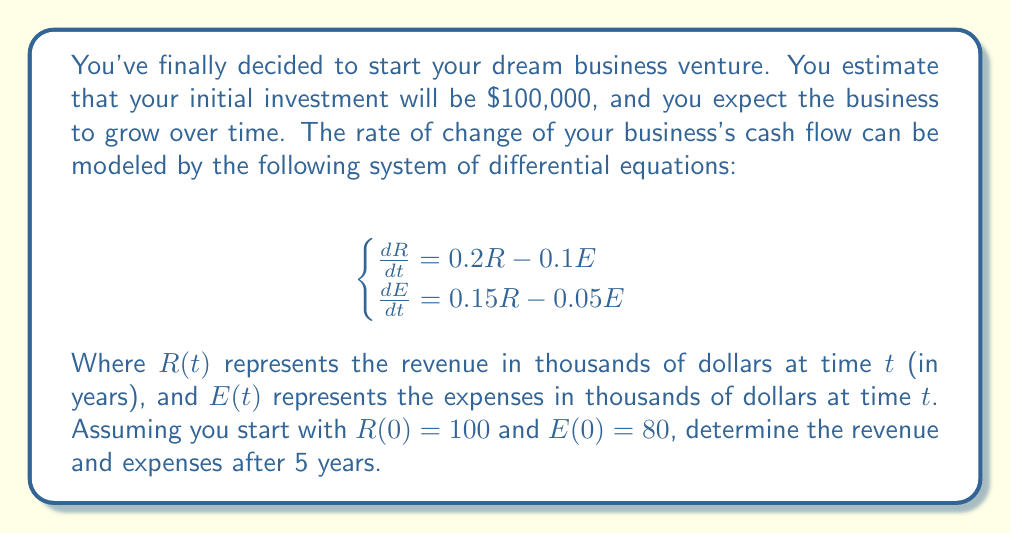What is the answer to this math problem? To solve this system of differential equations, we'll use the eigenvalue method:

1) First, write the system in matrix form:
   $$\frac{d}{dt}\begin{bmatrix} R \\ E \end{bmatrix} = \begin{bmatrix} 0.2 & -0.1 \\ 0.15 & -0.05 \end{bmatrix}\begin{bmatrix} R \\ E \end{bmatrix}$$

2) Find the eigenvalues by solving $\det(A - \lambda I) = 0$:
   $$\det\begin{bmatrix} 0.2-\lambda & -0.1 \\ 0.15 & -0.05-\lambda \end{bmatrix} = 0$$
   $$(0.2-\lambda)(-0.05-\lambda) - (-0.1)(0.15) = 0$$
   $$\lambda^2 - 0.15\lambda - 0.025 = 0$$
   Solving this quadratic equation gives: $\lambda_1 \approx 0.1789$ and $\lambda_2 \approx -0.0289$

3) Find the eigenvectors for each eigenvalue:
   For $\lambda_1 \approx 0.1789$: $\vec{v_1} \approx \begin{bmatrix} 1 \\ 1.3789 \end{bmatrix}$
   For $\lambda_2 \approx -0.0289$: $\vec{v_2} \approx \begin{bmatrix} 1 \\ -0.3789 \end{bmatrix}$

4) The general solution is:
   $$\begin{bmatrix} R(t) \\ E(t) \end{bmatrix} = c_1e^{0.1789t}\begin{bmatrix} 1 \\ 1.3789 \end{bmatrix} + c_2e^{-0.0289t}\begin{bmatrix} 1 \\ -0.3789 \end{bmatrix}$$

5) Use the initial conditions to find $c_1$ and $c_2$:
   $$\begin{bmatrix} 100 \\ 80 \end{bmatrix} = c_1\begin{bmatrix} 1 \\ 1.3789 \end{bmatrix} + c_2\begin{bmatrix} 1 \\ -0.3789 \end{bmatrix}$$
   Solving this system gives: $c_1 \approx 84.8485$ and $c_2 \approx 15.1515$

6) The final solution is:
   $$\begin{bmatrix} R(t) \\ E(t) \end{bmatrix} = 84.8485e^{0.1789t}\begin{bmatrix} 1 \\ 1.3789 \end{bmatrix} + 15.1515e^{-0.0289t}\begin{bmatrix} 1 \\ -0.3789 \end{bmatrix}$$

7) To find R(5) and E(5), substitute t = 5:
   $$R(5) \approx 84.8485e^{0.1789(5)} + 15.1515e^{-0.0289(5)} \approx 205.8281$$
   $$E(5) \approx 84.8485(1.3789)e^{0.1789(5)} - 15.1515(0.3789)e^{-0.0289(5)} \approx 276.9087$$
Answer: After 5 years, the revenue R(5) ≈ $205,828 and the expenses E(5) ≈ $276,909. 